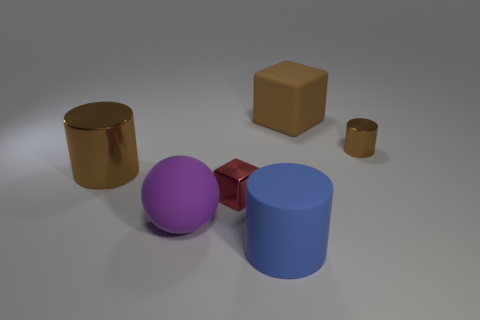There is a brown metal object to the left of the tiny brown cylinder; is its size the same as the brown metal thing to the right of the large matte block?
Provide a short and direct response. No. There is a metallic object behind the brown object that is in front of the brown shiny object that is right of the red block; what color is it?
Give a very brief answer. Brown. Is there another red shiny thing that has the same shape as the red shiny object?
Your answer should be very brief. No. Is the number of tiny red shiny objects to the right of the large blue matte cylinder greater than the number of big brown blocks?
Provide a short and direct response. No. How many metallic objects are either purple objects or brown objects?
Your answer should be very brief. 2. What is the size of the cylinder that is both to the right of the big brown metallic object and behind the big blue thing?
Offer a very short reply. Small. Is there a large cylinder that is on the right side of the matte thing that is in front of the purple rubber ball?
Provide a succinct answer. No. What number of big brown objects are to the left of the purple matte sphere?
Make the answer very short. 1. What color is the big matte thing that is the same shape as the large metallic object?
Your response must be concise. Blue. Do the big cylinder that is on the left side of the red thing and the cylinder in front of the big purple sphere have the same material?
Ensure brevity in your answer.  No. 